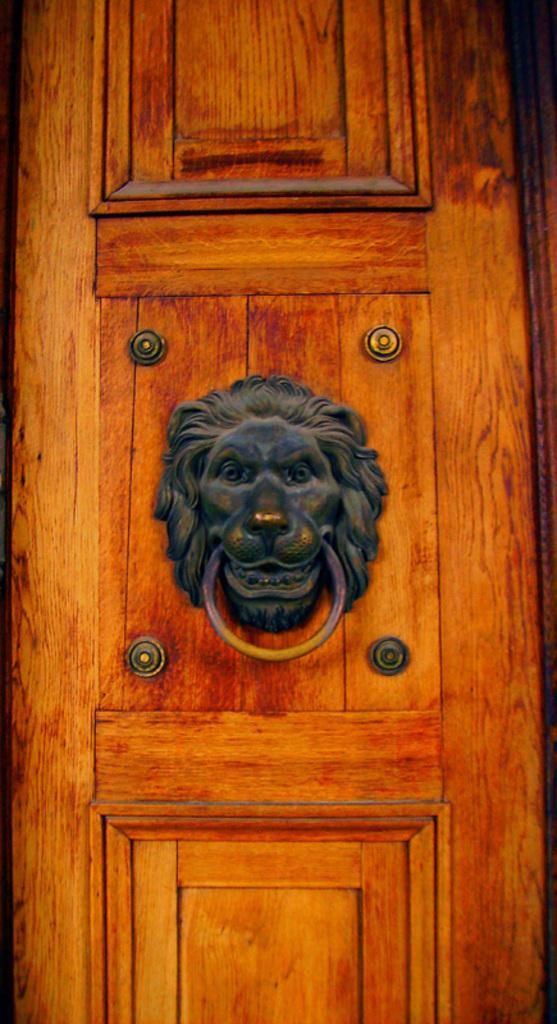What is the main feature of the door in the image? There is a lion head door knocker in the image. Is the door knocker attached to the door? Yes, the lion head door knocker is attached to the door. What type of stove can be seen in the image? There is no stove present in the image; it only features a lion head door knocker attached to a door. 